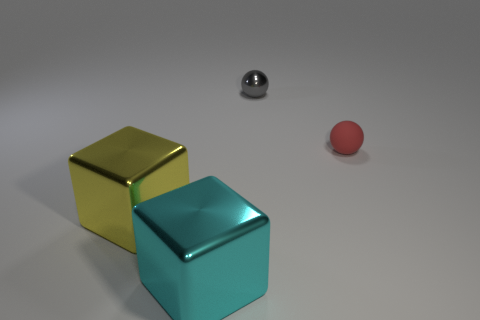Add 2 big red rubber things. How many objects exist? 6 Subtract all cyan blocks. How many blocks are left? 1 Add 2 big things. How many big things are left? 4 Add 4 cyan blocks. How many cyan blocks exist? 5 Subtract 0 brown blocks. How many objects are left? 4 Subtract 2 balls. How many balls are left? 0 Subtract all blue spheres. Subtract all blue cylinders. How many spheres are left? 2 Subtract all tiny objects. Subtract all yellow things. How many objects are left? 1 